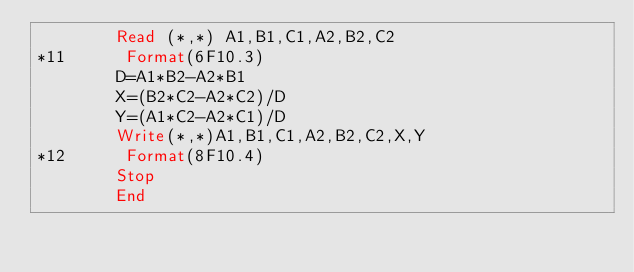<code> <loc_0><loc_0><loc_500><loc_500><_FORTRAN_>        Read (*,*) A1,B1,C1,A2,B2,C2
*11      Format(6F10.3)
        D=A1*B2-A2*B1
        X=(B2*C2-A2*C2)/D
        Y=(A1*C2-A2*C1)/D
        Write(*,*)A1,B1,C1,A2,B2,C2,X,Y
*12      Format(8F10.4)
        Stop
        End
</code> 